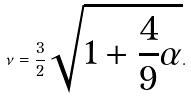<formula> <loc_0><loc_0><loc_500><loc_500>\nu = \frac { 3 } { 2 } \sqrt { 1 + \frac { 4 } { 9 } \alpha } .</formula> 